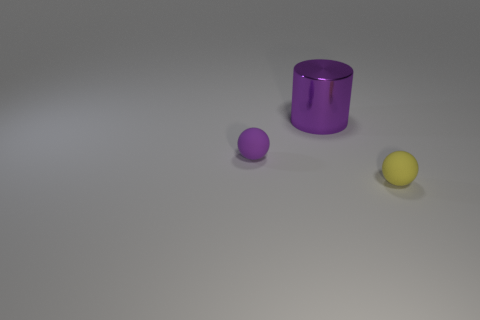Add 3 small green shiny balls. How many objects exist? 6 Subtract all cylinders. How many objects are left? 2 Add 1 purple objects. How many purple objects exist? 3 Subtract 0 green balls. How many objects are left? 3 Subtract all purple matte objects. Subtract all tiny purple balls. How many objects are left? 1 Add 3 things. How many things are left? 6 